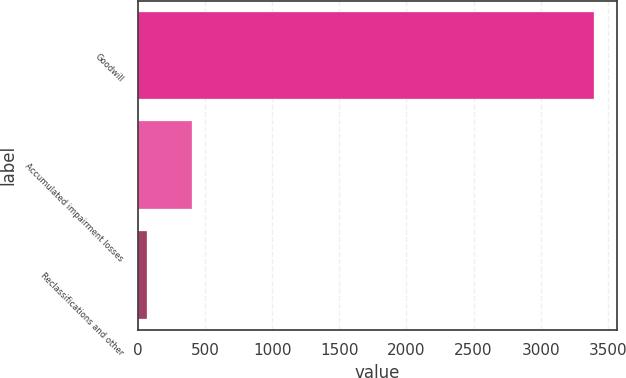Convert chart to OTSL. <chart><loc_0><loc_0><loc_500><loc_500><bar_chart><fcel>Goodwill<fcel>Accumulated impairment losses<fcel>Reclassifications and other<nl><fcel>3396<fcel>402.6<fcel>70<nl></chart> 